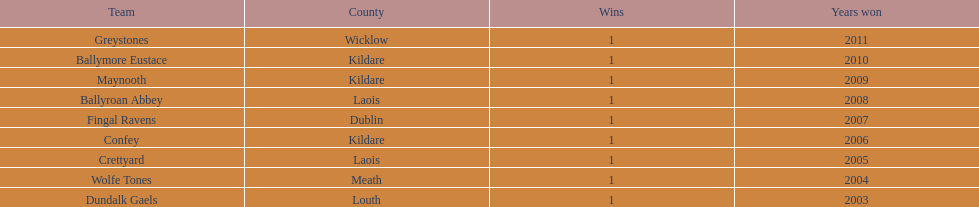Which team was the previous winner before ballyroan abbey in 2008? Fingal Ravens. 